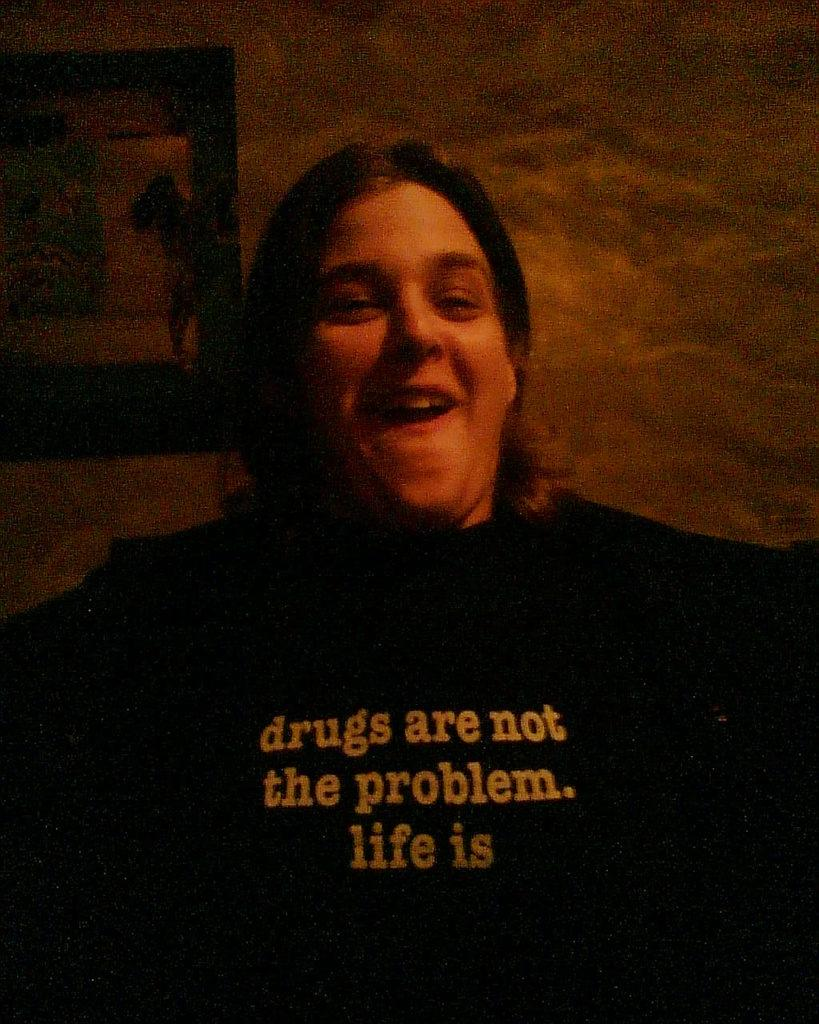Who or what is the main subject of the image? There is a person in the image. What is the person wearing? The person is wearing a black dress. What else can be seen in the image besides the person? There are objects in the image. Can you describe the background of the image? The background of the image is dark. What type of camp can be seen in the image? There is no camp present in the image. Is there a fireman visible in the image? There is no fireman present in the image. 